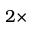<formula> <loc_0><loc_0><loc_500><loc_500>2 \times</formula> 